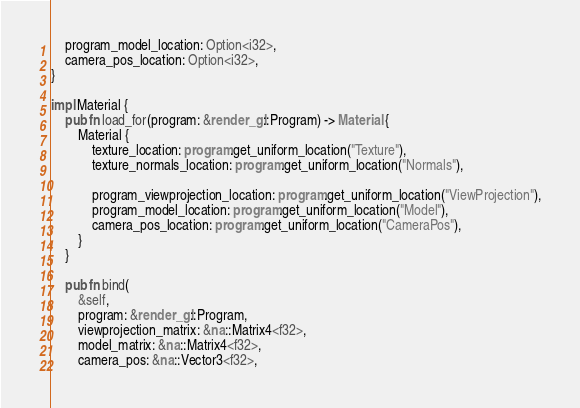Convert code to text. <code><loc_0><loc_0><loc_500><loc_500><_Rust_>    program_model_location: Option<i32>,
    camera_pos_location: Option<i32>,
}

impl Material {
    pub fn load_for(program: &render_gl::Program) -> Material {
        Material {
            texture_location: program.get_uniform_location("Texture"),
            texture_normals_location: program.get_uniform_location("Normals"),

            program_viewprojection_location: program.get_uniform_location("ViewProjection"),
            program_model_location: program.get_uniform_location("Model"),
            camera_pos_location: program.get_uniform_location("CameraPos"),
        }
    }

    pub fn bind(
        &self,
        program: &render_gl::Program,
        viewprojection_matrix: &na::Matrix4<f32>,
        model_matrix: &na::Matrix4<f32>,
        camera_pos: &na::Vector3<f32>,</code> 